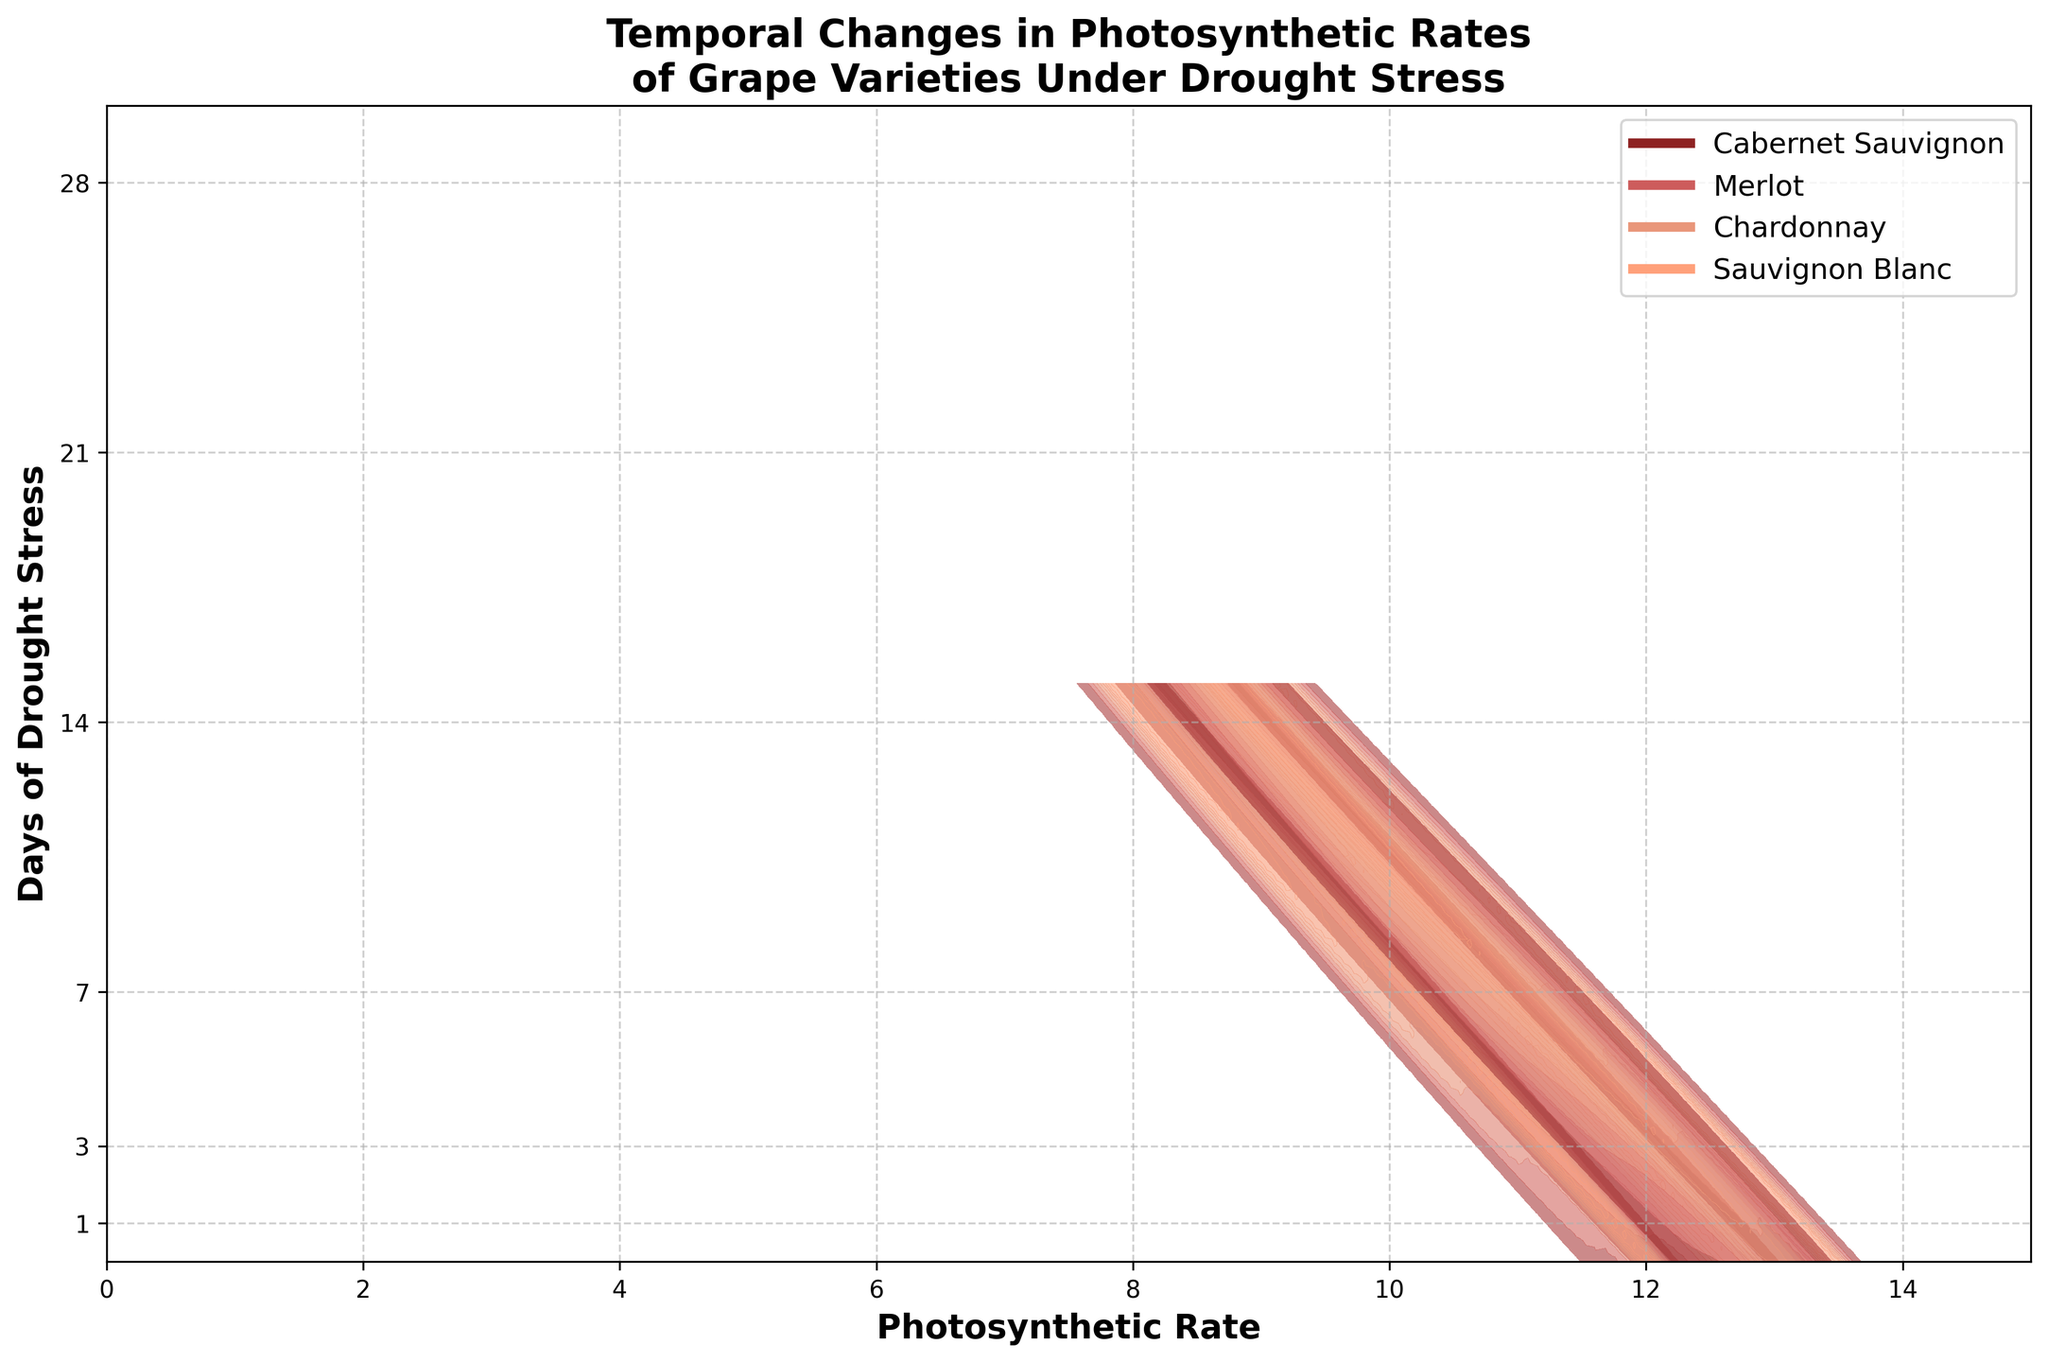What is the title of the plot? The title of the plot is typically located at the top of the figure, and it provides a summary of what the figure is about.
Answer: Temporal Changes in Photosynthetic Rates of Grape Varieties Under Drought Stress How many grape varieties are included in the study? There are clear distinctions in the ridgeline plot for different colors corresponding to different varieties. The legend lists the names of these varieties.
Answer: Four Which grape variety experienced the most drastic decrease in photosynthetic rate by day 28? By comparing the photosynthetic rates of all grape varieties on day 28, we can identify which variety has the largest drop.
Answer: Chardonnay What is the range of days over which the data was collected? The y-axis lists the days on which measurements were taken, from the start to the end of the observation period.
Answer: 1 to 28 On which day did Merlot have its highest photosynthetic rate? By locating where the ridgeline for Merlot reaches its peak on the x-axis, we can determine the day associated with this peak on the y-axis.
Answer: Day 1 Compare the photosynthetic rates between Cabernet Sauvignon and Sauvignon Blanc on day 14. Which one is higher? By observing the ridgelines for both varieties at day 14, we can compare their peak positions on the x-axis.
Answer: Sauvignon Blanc What is the trend for photosynthetic rates over time for all varieties? By looking at the overall pattern of all the ridgelines from day 1 to day 28, we can identify whether the photosynthetic rates are increasing, decreasing, or staying the same.
Answer: Decreasing Which variety maintains the highest photosynthetic rate throughout the study? By identifying which ridgeline is consistently higher or has higher peaks than others across all days, we can pinpoint the variety in question.
Answer: Merlot How does the photosynthetic rate of Chardonnay on day 7 compare to day 3? By comparing the positions of the Chardonnay peaks on day 7 and day 3, we can assess whether the rate increased, decreased, or remained the same.
Answer: Lower on day 7 Are there any days when the photosynthetic rates are roughly similar for all varieties? By checking if there are any days where the ridgelines for all varieties converge closely, we can determine if there's such a period.
Answer: Day 28 